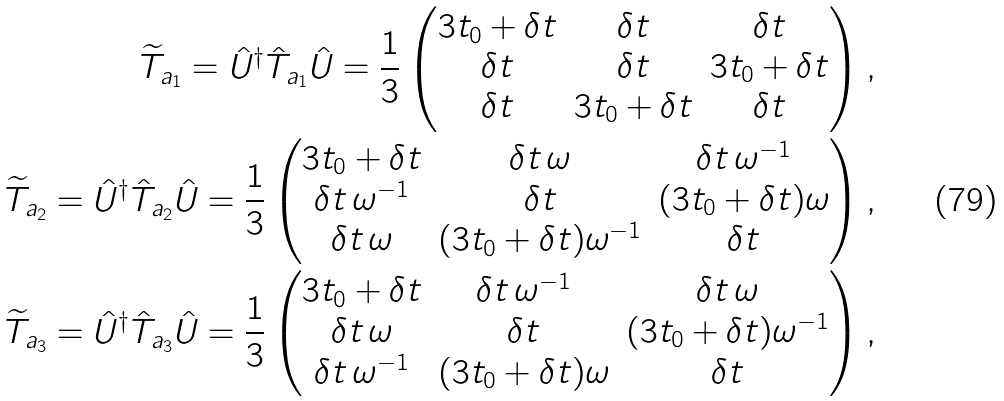<formula> <loc_0><loc_0><loc_500><loc_500>\widetilde { T } _ { { a } _ { 1 } } = \hat { U } ^ { \dagger } \hat { T } _ { { a } _ { 1 } } \hat { U } = \frac { 1 } { 3 } \begin{pmatrix} 3 t _ { 0 } + \delta t & \delta t & \delta t \\ \delta t & \delta t & 3 t _ { 0 } + \delta t \\ \delta t & 3 t _ { 0 } + \delta t & \delta t \end{pmatrix} , \\ \widetilde { T } _ { { a } _ { 2 } } = \hat { U } ^ { \dagger } \hat { T } _ { { a } _ { 2 } } \hat { U } = \frac { 1 } { 3 } \begin{pmatrix} 3 t _ { 0 } + \delta t & \delta t \, \omega & \delta t \, \omega ^ { - 1 } \\ \delta t \, \omega ^ { - 1 } & \delta t & ( 3 t _ { 0 } + \delta t ) \omega \\ \delta t \, \omega & ( 3 t _ { 0 } + \delta t ) \omega ^ { - 1 } & \delta t \end{pmatrix} , \\ \widetilde { T } _ { { a } _ { 3 } } = \hat { U } ^ { \dagger } \hat { T } _ { { a } _ { 3 } } \hat { U } = \frac { 1 } { 3 } \begin{pmatrix} 3 t _ { 0 } + \delta t & \delta t \, \omega ^ { - 1 } & \delta t \, \omega \\ \delta t \, \omega & \delta t & ( 3 t _ { 0 } + \delta t ) \omega ^ { - 1 } \\ \delta t \, \omega ^ { - 1 } & ( 3 t _ { 0 } + \delta t ) \omega & \delta t \end{pmatrix} ,</formula> 